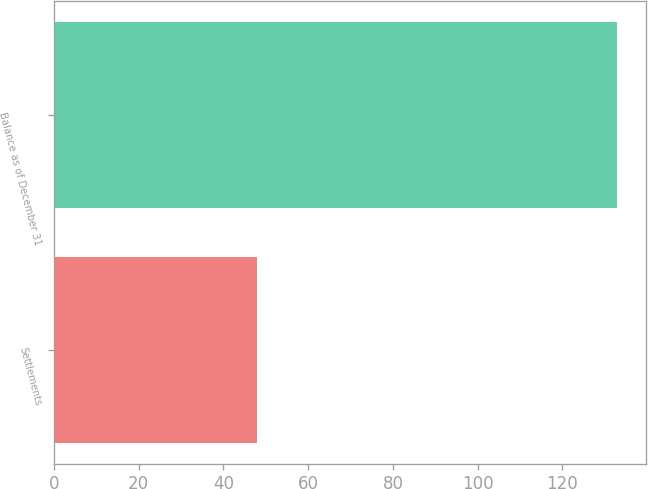Convert chart to OTSL. <chart><loc_0><loc_0><loc_500><loc_500><bar_chart><fcel>Settlements<fcel>Balance as of December 31<nl><fcel>48<fcel>133<nl></chart> 